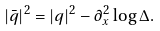Convert formula to latex. <formula><loc_0><loc_0><loc_500><loc_500>| \bar { q } | ^ { 2 } = | q | ^ { 2 } - \partial _ { x } ^ { 2 } \log \Delta .</formula> 